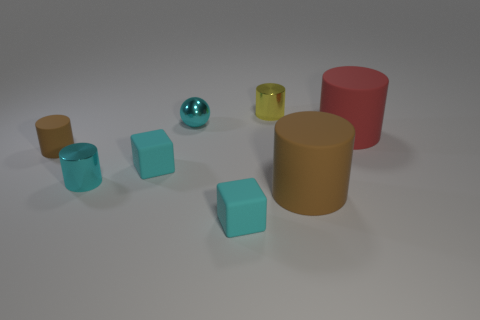Can you tell me the colors of the cylinders in the image? Sure, there are four cylinders in the image. Starting with the smallest, it's red. The other three cylinders are yellow, tan, and the largest is a darker shade of tan or brown. 